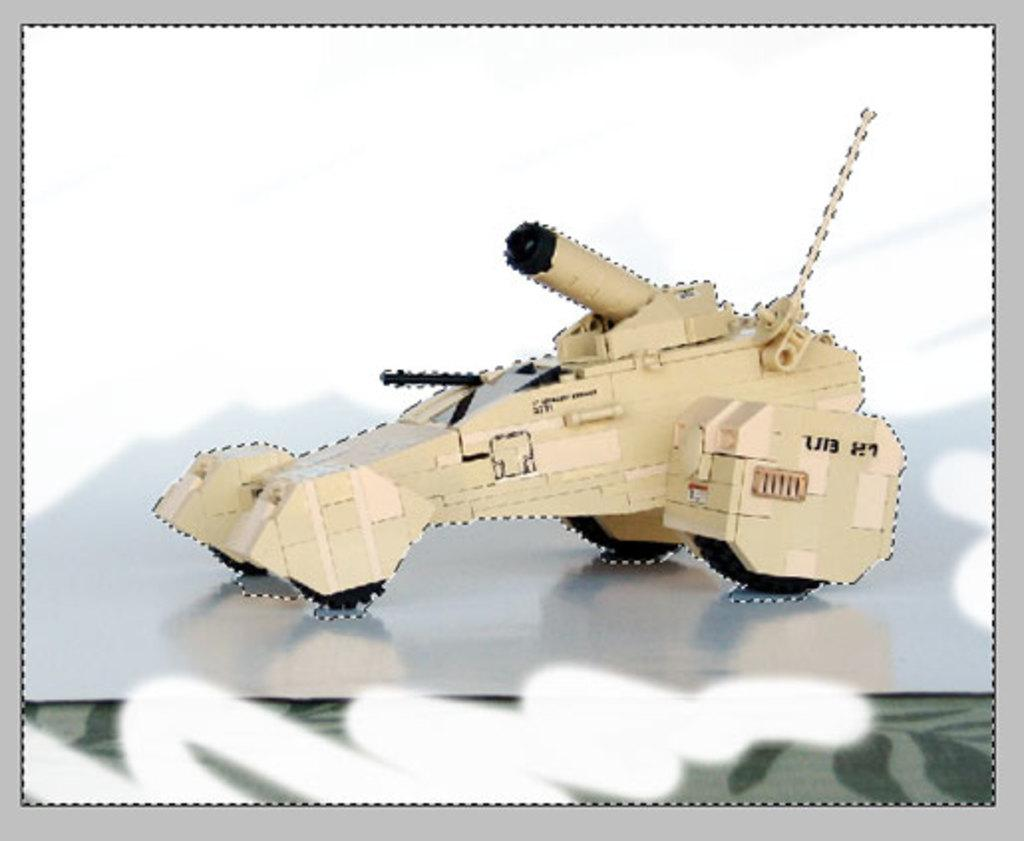What type of vehicle is shown in the image? There is a military vehicle depicted in the image. Can you describe the surface on which the vehicle is placed? The military vehicle is on a surface. Are there any visible edges or boundaries in the image? Yes, the image has borders. Reasoning: Let' Let's think step by step in order to produce the conversation. We start by identifying the main subject in the image, which is the military vehicle. Then, we expand the conversation to include details about the vehicle's placement and the presence of borders in the image. Each question is designed to elicit a specific detail about the image that is known from the provided facts. Absurd Question/Answer: What color is the silver worm on the committee in the image? There is no silver worm or committee present in the image. 